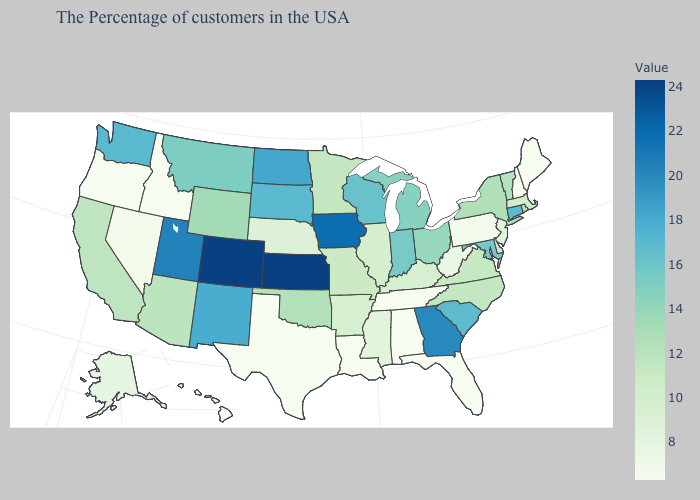Among the states that border Minnesota , which have the lowest value?
Write a very short answer. Wisconsin. Which states hav the highest value in the West?
Keep it brief. Colorado. Does Kansas have the highest value in the USA?
Give a very brief answer. Yes. Does New Jersey have the lowest value in the Northeast?
Short answer required. No. 